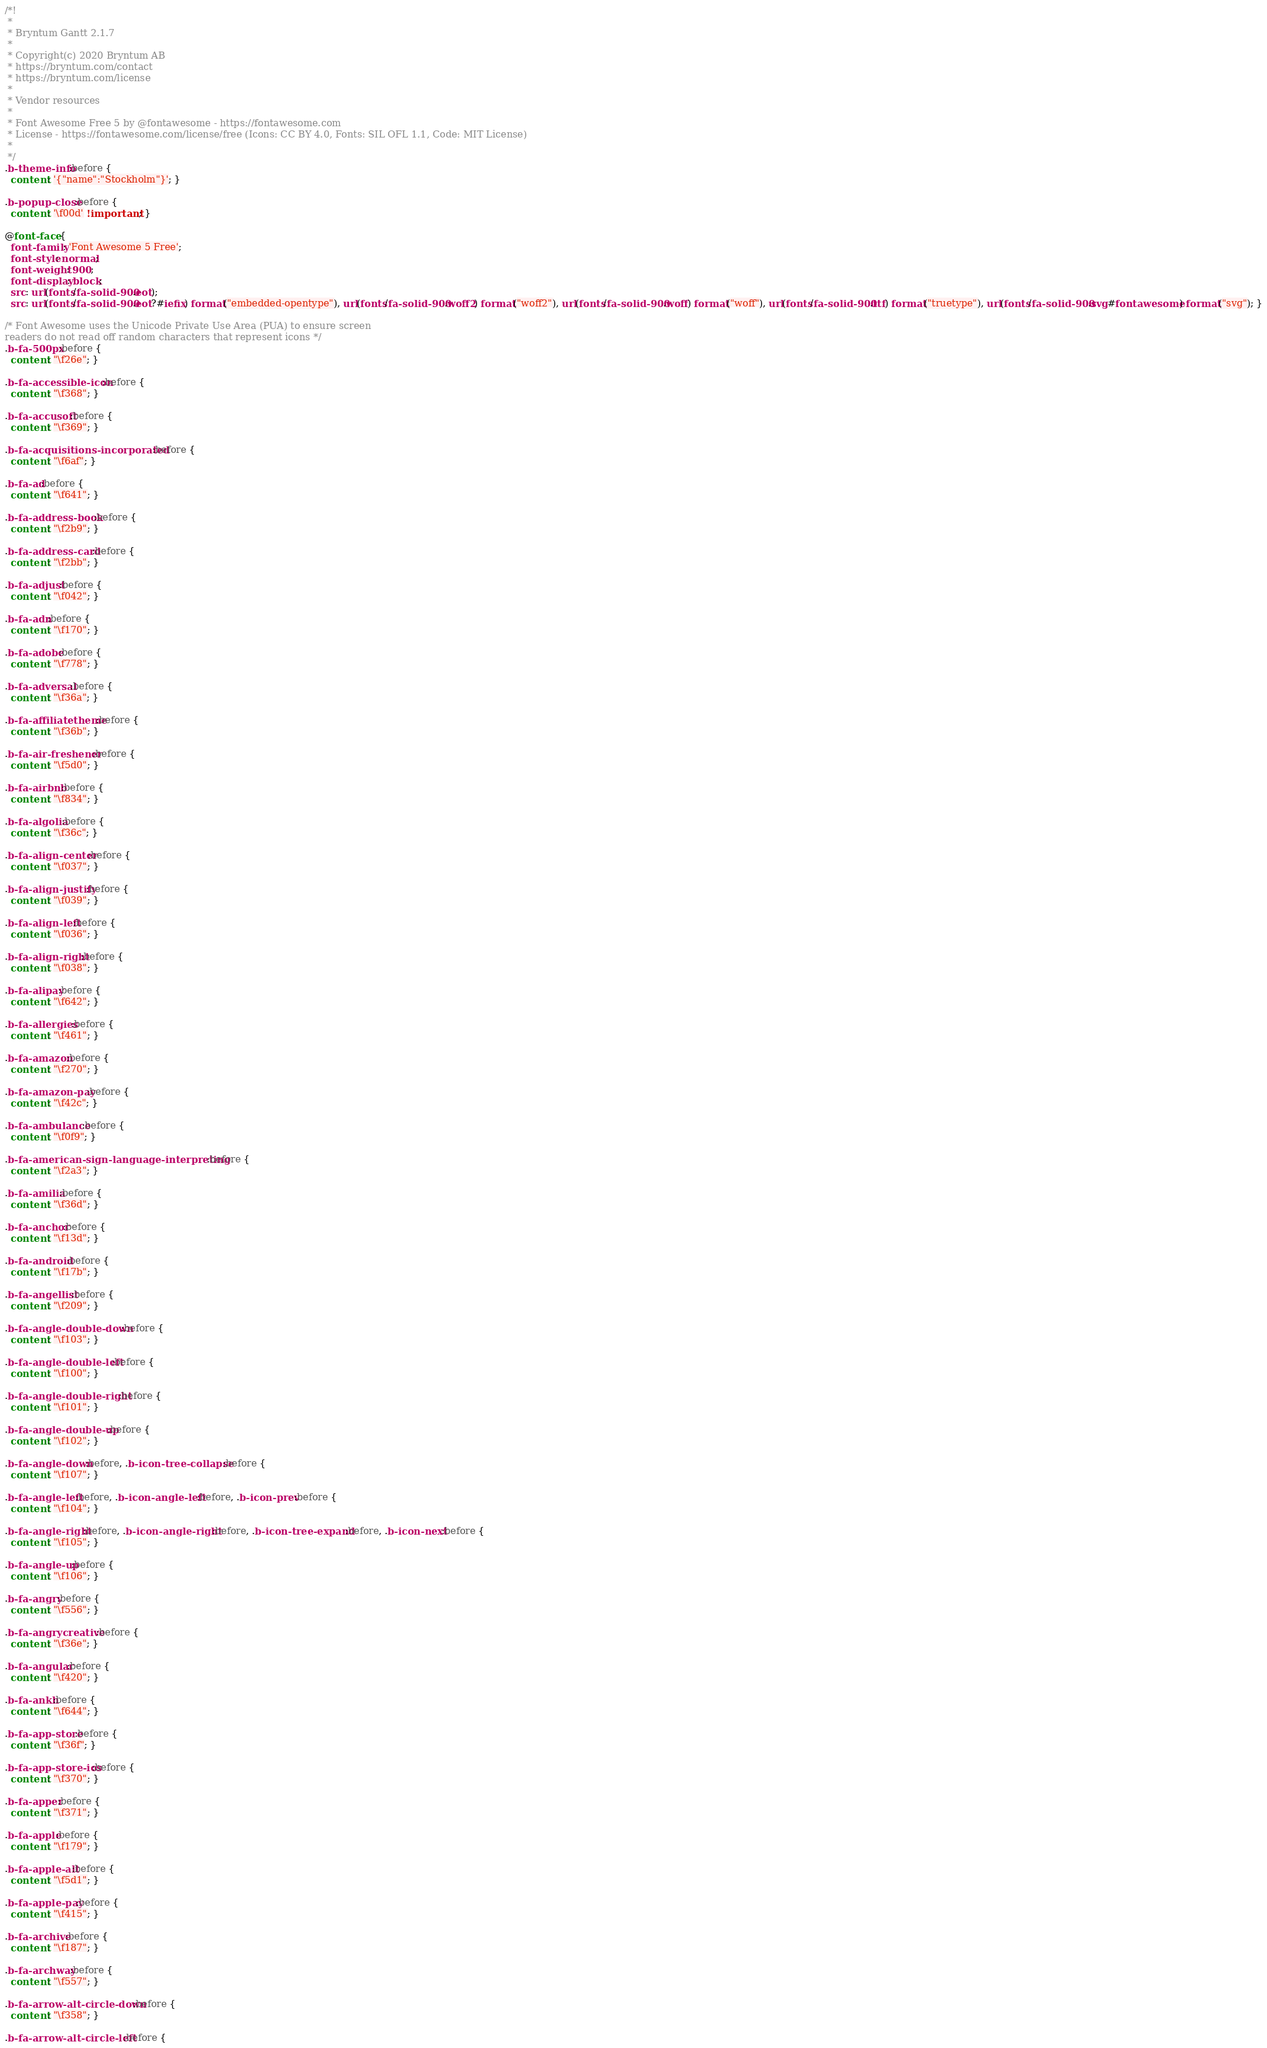Convert code to text. <code><loc_0><loc_0><loc_500><loc_500><_CSS_>/*!
 *
 * Bryntum Gantt 2.1.7
 *
 * Copyright(c) 2020 Bryntum AB
 * https://bryntum.com/contact
 * https://bryntum.com/license
 *
 * Vendor resources
 *
 * Font Awesome Free 5 by @fontawesome - https://fontawesome.com
 * License - https://fontawesome.com/license/free (Icons: CC BY 4.0, Fonts: SIL OFL 1.1, Code: MIT License)
 *
 */
.b-theme-info:before {
  content: '{"name":"Stockholm"}'; }

.b-popup-close:before {
  content: '\f00d' !important; }

@font-face {
  font-family: 'Font Awesome 5 Free';
  font-style: normal;
  font-weight: 900;
  font-display: block;
  src: url(fonts/fa-solid-900.eot);
  src: url(fonts/fa-solid-900.eot?#iefix) format("embedded-opentype"), url(fonts/fa-solid-900.woff2) format("woff2"), url(fonts/fa-solid-900.woff) format("woff"), url(fonts/fa-solid-900.ttf) format("truetype"), url(fonts/fa-solid-900.svg#fontawesome) format("svg"); }

/* Font Awesome uses the Unicode Private Use Area (PUA) to ensure screen
readers do not read off random characters that represent icons */
.b-fa-500px:before {
  content: "\f26e"; }

.b-fa-accessible-icon:before {
  content: "\f368"; }

.b-fa-accusoft:before {
  content: "\f369"; }

.b-fa-acquisitions-incorporated:before {
  content: "\f6af"; }

.b-fa-ad:before {
  content: "\f641"; }

.b-fa-address-book:before {
  content: "\f2b9"; }

.b-fa-address-card:before {
  content: "\f2bb"; }

.b-fa-adjust:before {
  content: "\f042"; }

.b-fa-adn:before {
  content: "\f170"; }

.b-fa-adobe:before {
  content: "\f778"; }

.b-fa-adversal:before {
  content: "\f36a"; }

.b-fa-affiliatetheme:before {
  content: "\f36b"; }

.b-fa-air-freshener:before {
  content: "\f5d0"; }

.b-fa-airbnb:before {
  content: "\f834"; }

.b-fa-algolia:before {
  content: "\f36c"; }

.b-fa-align-center:before {
  content: "\f037"; }

.b-fa-align-justify:before {
  content: "\f039"; }

.b-fa-align-left:before {
  content: "\f036"; }

.b-fa-align-right:before {
  content: "\f038"; }

.b-fa-alipay:before {
  content: "\f642"; }

.b-fa-allergies:before {
  content: "\f461"; }

.b-fa-amazon:before {
  content: "\f270"; }

.b-fa-amazon-pay:before {
  content: "\f42c"; }

.b-fa-ambulance:before {
  content: "\f0f9"; }

.b-fa-american-sign-language-interpreting:before {
  content: "\f2a3"; }

.b-fa-amilia:before {
  content: "\f36d"; }

.b-fa-anchor:before {
  content: "\f13d"; }

.b-fa-android:before {
  content: "\f17b"; }

.b-fa-angellist:before {
  content: "\f209"; }

.b-fa-angle-double-down:before {
  content: "\f103"; }

.b-fa-angle-double-left:before {
  content: "\f100"; }

.b-fa-angle-double-right:before {
  content: "\f101"; }

.b-fa-angle-double-up:before {
  content: "\f102"; }

.b-fa-angle-down:before, .b-icon-tree-collapse:before {
  content: "\f107"; }

.b-fa-angle-left:before, .b-icon-angle-left:before, .b-icon-prev:before {
  content: "\f104"; }

.b-fa-angle-right:before, .b-icon-angle-right:before, .b-icon-tree-expand:before, .b-icon-next:before {
  content: "\f105"; }

.b-fa-angle-up:before {
  content: "\f106"; }

.b-fa-angry:before {
  content: "\f556"; }

.b-fa-angrycreative:before {
  content: "\f36e"; }

.b-fa-angular:before {
  content: "\f420"; }

.b-fa-ankh:before {
  content: "\f644"; }

.b-fa-app-store:before {
  content: "\f36f"; }

.b-fa-app-store-ios:before {
  content: "\f370"; }

.b-fa-apper:before {
  content: "\f371"; }

.b-fa-apple:before {
  content: "\f179"; }

.b-fa-apple-alt:before {
  content: "\f5d1"; }

.b-fa-apple-pay:before {
  content: "\f415"; }

.b-fa-archive:before {
  content: "\f187"; }

.b-fa-archway:before {
  content: "\f557"; }

.b-fa-arrow-alt-circle-down:before {
  content: "\f358"; }

.b-fa-arrow-alt-circle-left:before {</code> 